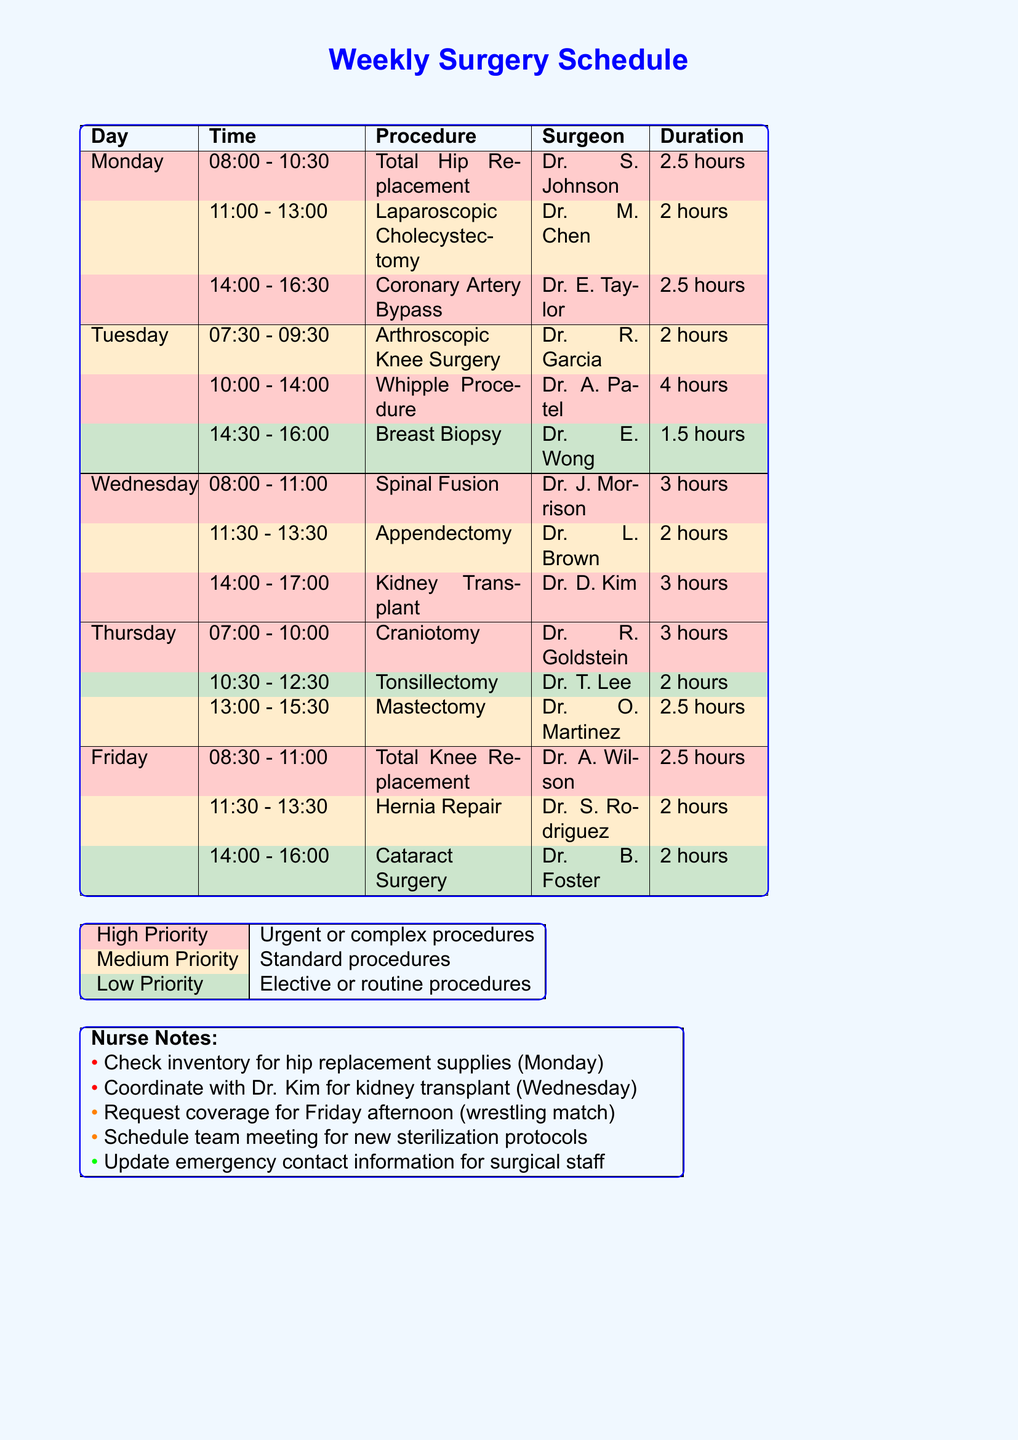What is the total duration of surgeries on Monday? The total duration on Monday is calculated by adding the durations of all surgeries: 2.5 hours + 2 hours + 2.5 hours = 7 hours.
Answer: 7 hours Who is the surgeon for the Whipple Procedure? The surgeon for the Whipple Procedure is mentioned in the schedule under Tuesday's section.
Answer: Dr. Amanda Patel How many high priority surgeries are scheduled on Wednesday? To determine this, we review the surgeries on Wednesday and count the ones marked as high priority. There are two high priority surgeries: Spinal Fusion and Kidney Transplant.
Answer: 2 When does the Total Hip Replacement surgery start? The start time for the Total Hip Replacement surgery is specified in the schedule for Monday.
Answer: 08:00 What is the priority level for the Tonsillectomy procedure? The priority level for the Tonsillectomy is indicated in the Thursday section of the schedule.
Answer: Low 